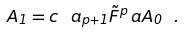Convert formula to latex. <formula><loc_0><loc_0><loc_500><loc_500>A _ { 1 } = c ^ { \ } a _ { p + 1 } \tilde { F } ^ { p } _ { \ } a A _ { 0 } \ .</formula> 